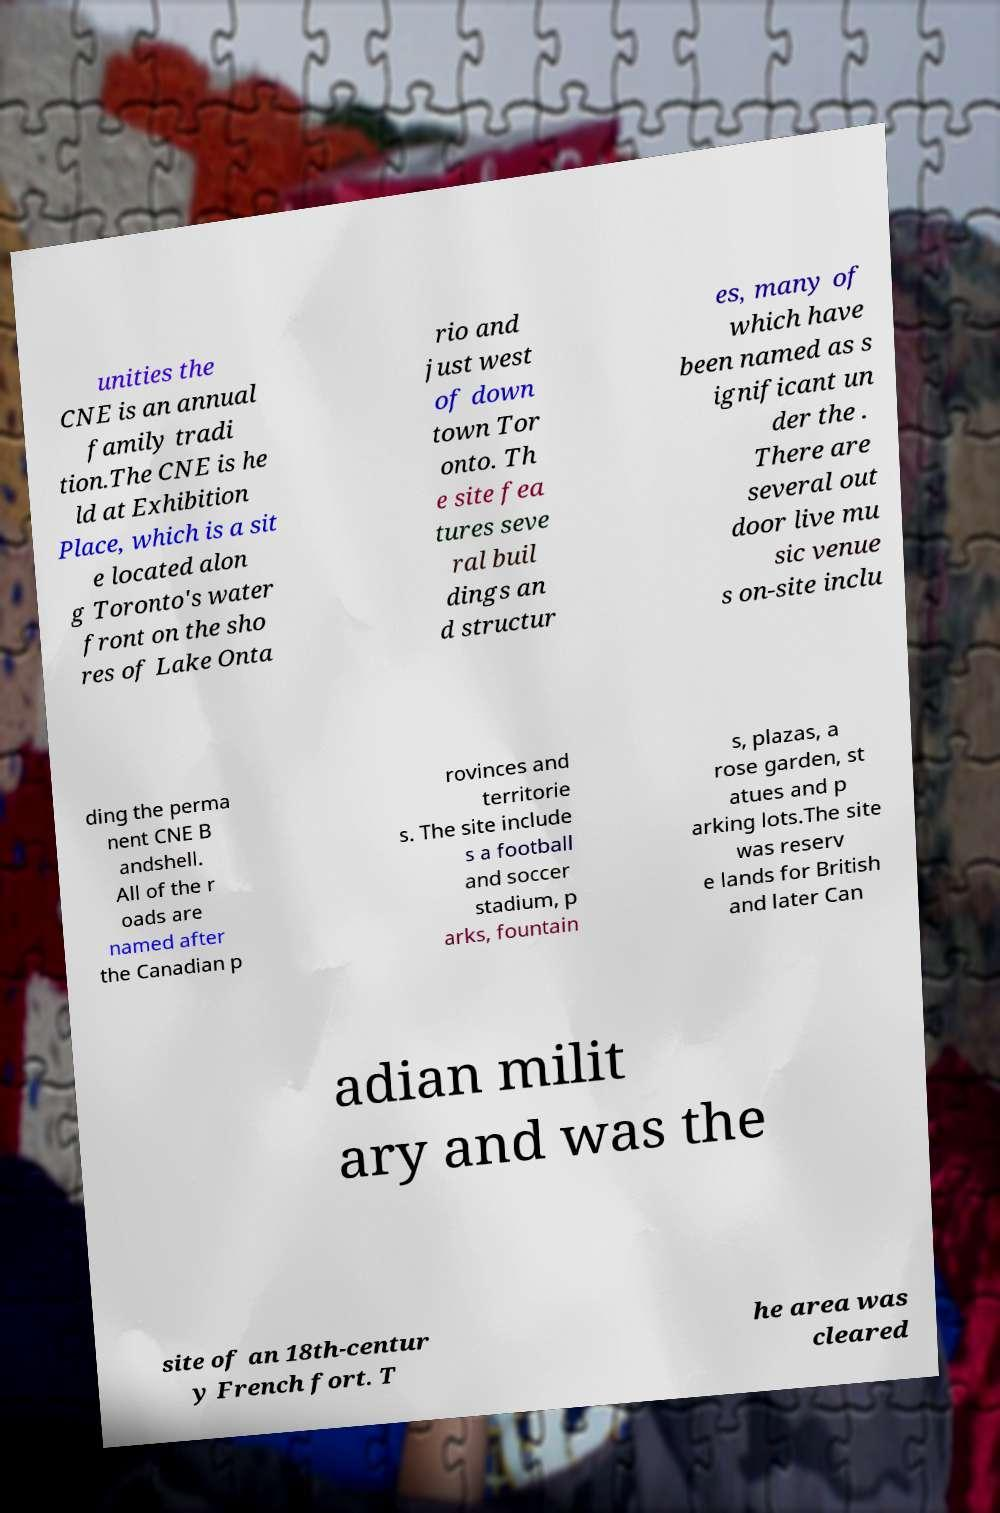Can you read and provide the text displayed in the image?This photo seems to have some interesting text. Can you extract and type it out for me? unities the CNE is an annual family tradi tion.The CNE is he ld at Exhibition Place, which is a sit e located alon g Toronto's water front on the sho res of Lake Onta rio and just west of down town Tor onto. Th e site fea tures seve ral buil dings an d structur es, many of which have been named as s ignificant un der the . There are several out door live mu sic venue s on-site inclu ding the perma nent CNE B andshell. All of the r oads are named after the Canadian p rovinces and territorie s. The site include s a football and soccer stadium, p arks, fountain s, plazas, a rose garden, st atues and p arking lots.The site was reserv e lands for British and later Can adian milit ary and was the site of an 18th-centur y French fort. T he area was cleared 